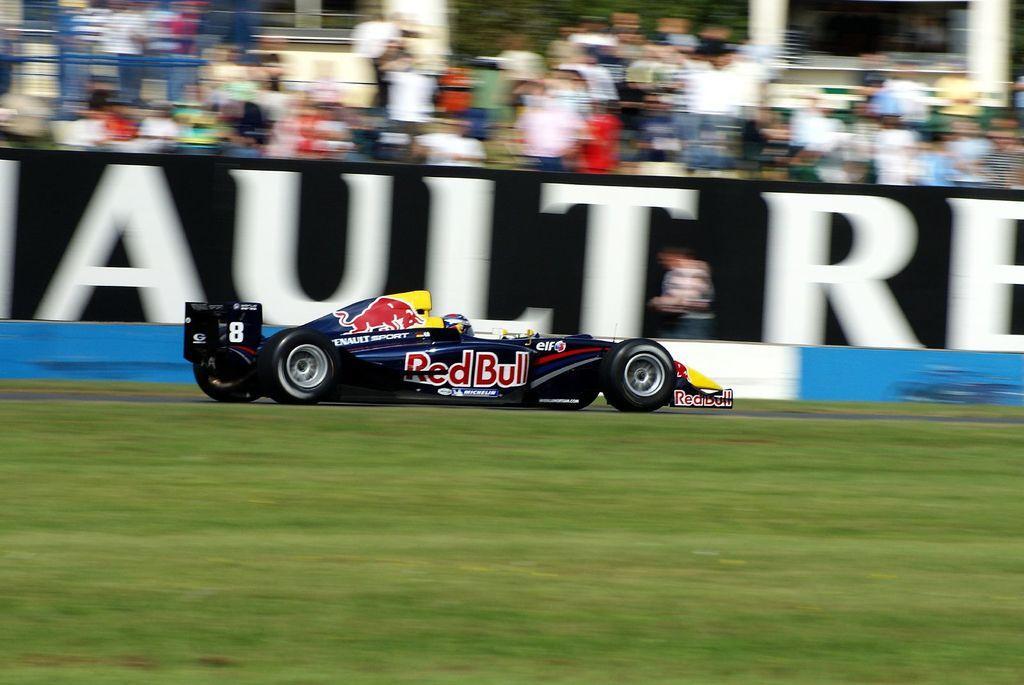In one or two sentences, can you explain what this image depicts? In this image, we can see a vehicle on the ground and in the background, there is a board and we can see some people, pillars and there is a railing. 